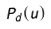Convert formula to latex. <formula><loc_0><loc_0><loc_500><loc_500>P _ { d } ( u )</formula> 